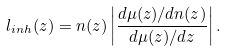Convert formula to latex. <formula><loc_0><loc_0><loc_500><loc_500>l _ { i n h } ( z ) = n ( z ) \left | \frac { d \mu ( z ) / d n ( z ) } { d \mu ( z ) / d z } \right | .</formula> 